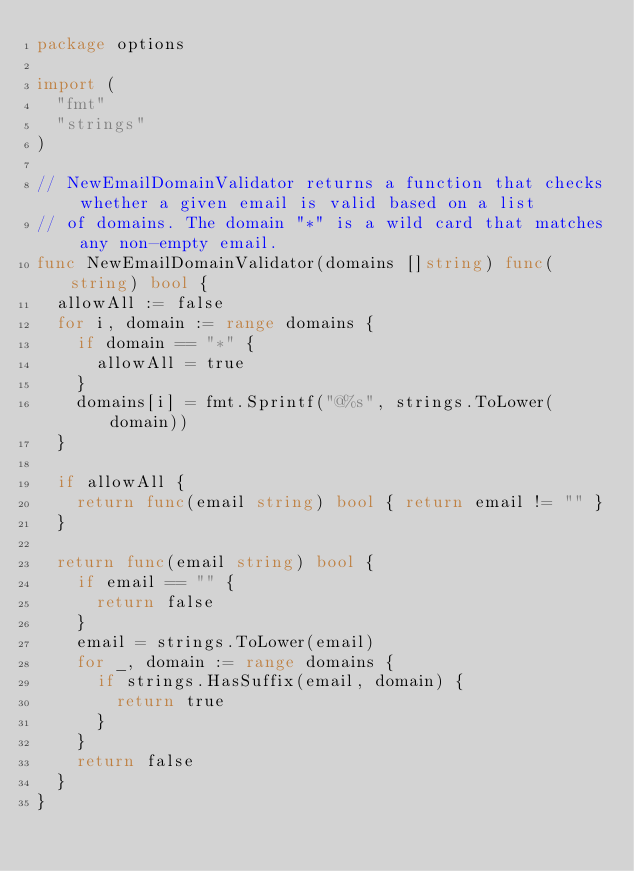Convert code to text. <code><loc_0><loc_0><loc_500><loc_500><_Go_>package options

import (
	"fmt"
	"strings"
)

// NewEmailDomainValidator returns a function that checks whether a given email is valid based on a list
// of domains. The domain "*" is a wild card that matches any non-empty email.
func NewEmailDomainValidator(domains []string) func(string) bool {
	allowAll := false
	for i, domain := range domains {
		if domain == "*" {
			allowAll = true
		}
		domains[i] = fmt.Sprintf("@%s", strings.ToLower(domain))
	}

	if allowAll {
		return func(email string) bool { return email != "" }
	}

	return func(email string) bool {
		if email == "" {
			return false
		}
		email = strings.ToLower(email)
		for _, domain := range domains {
			if strings.HasSuffix(email, domain) {
				return true
			}
		}
		return false
	}
}
</code> 